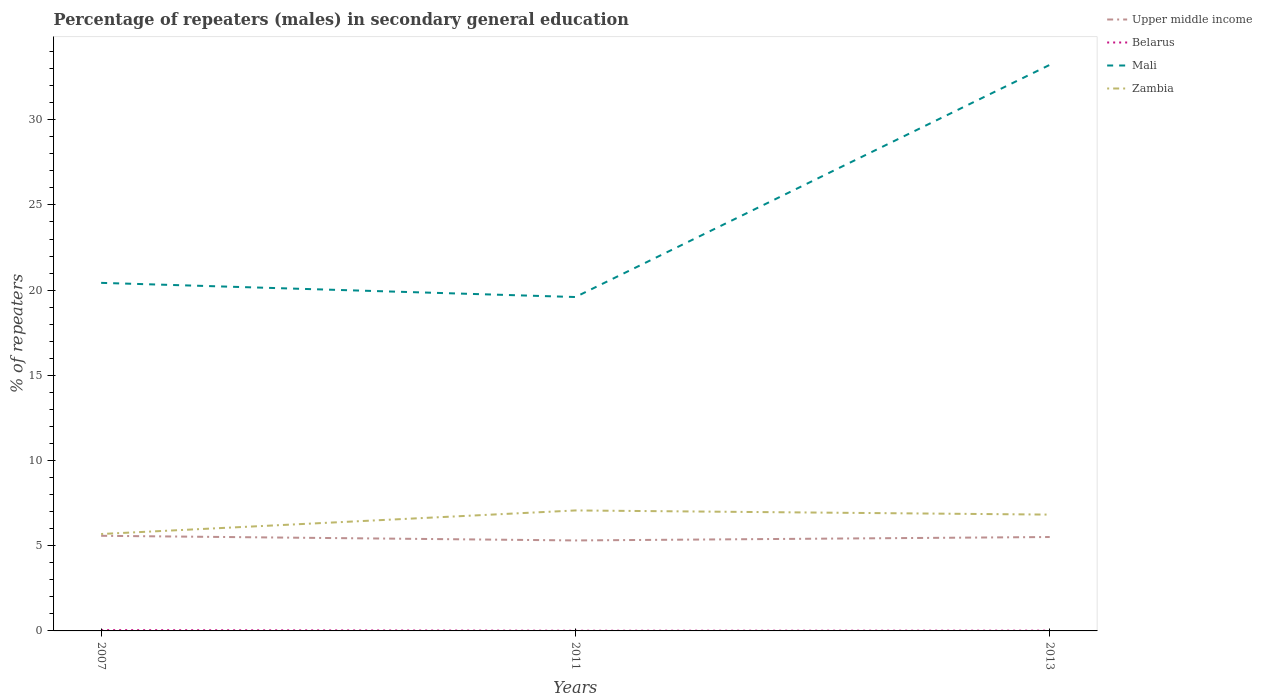How many different coloured lines are there?
Give a very brief answer. 4. Does the line corresponding to Belarus intersect with the line corresponding to Upper middle income?
Provide a short and direct response. No. Is the number of lines equal to the number of legend labels?
Offer a terse response. Yes. Across all years, what is the maximum percentage of male repeaters in Zambia?
Give a very brief answer. 5.69. In which year was the percentage of male repeaters in Upper middle income maximum?
Your answer should be compact. 2011. What is the total percentage of male repeaters in Upper middle income in the graph?
Offer a very short reply. 0.27. What is the difference between the highest and the second highest percentage of male repeaters in Mali?
Your answer should be compact. 13.63. What is the difference between the highest and the lowest percentage of male repeaters in Upper middle income?
Ensure brevity in your answer.  2. Is the percentage of male repeaters in Upper middle income strictly greater than the percentage of male repeaters in Zambia over the years?
Your response must be concise. Yes. What is the difference between two consecutive major ticks on the Y-axis?
Offer a terse response. 5. Does the graph contain grids?
Provide a short and direct response. No. What is the title of the graph?
Your answer should be compact. Percentage of repeaters (males) in secondary general education. What is the label or title of the X-axis?
Offer a very short reply. Years. What is the label or title of the Y-axis?
Your answer should be very brief. % of repeaters. What is the % of repeaters of Upper middle income in 2007?
Offer a very short reply. 5.58. What is the % of repeaters in Belarus in 2007?
Provide a short and direct response. 0.05. What is the % of repeaters in Mali in 2007?
Your answer should be very brief. 20.43. What is the % of repeaters of Zambia in 2007?
Your answer should be very brief. 5.69. What is the % of repeaters of Upper middle income in 2011?
Make the answer very short. 5.31. What is the % of repeaters of Belarus in 2011?
Ensure brevity in your answer.  0.01. What is the % of repeaters of Mali in 2011?
Give a very brief answer. 19.6. What is the % of repeaters of Zambia in 2011?
Make the answer very short. 7.07. What is the % of repeaters in Upper middle income in 2013?
Your answer should be very brief. 5.51. What is the % of repeaters in Belarus in 2013?
Your answer should be compact. 0.02. What is the % of repeaters in Mali in 2013?
Your answer should be compact. 33.22. What is the % of repeaters of Zambia in 2013?
Your response must be concise. 6.83. Across all years, what is the maximum % of repeaters of Upper middle income?
Your response must be concise. 5.58. Across all years, what is the maximum % of repeaters in Belarus?
Offer a very short reply. 0.05. Across all years, what is the maximum % of repeaters of Mali?
Keep it short and to the point. 33.22. Across all years, what is the maximum % of repeaters in Zambia?
Offer a terse response. 7.07. Across all years, what is the minimum % of repeaters in Upper middle income?
Your answer should be very brief. 5.31. Across all years, what is the minimum % of repeaters in Belarus?
Keep it short and to the point. 0.01. Across all years, what is the minimum % of repeaters in Mali?
Provide a short and direct response. 19.6. Across all years, what is the minimum % of repeaters in Zambia?
Provide a succinct answer. 5.69. What is the total % of repeaters in Upper middle income in the graph?
Give a very brief answer. 16.41. What is the total % of repeaters of Belarus in the graph?
Keep it short and to the point. 0.08. What is the total % of repeaters in Mali in the graph?
Keep it short and to the point. 73.25. What is the total % of repeaters in Zambia in the graph?
Ensure brevity in your answer.  19.59. What is the difference between the % of repeaters in Upper middle income in 2007 and that in 2011?
Give a very brief answer. 0.27. What is the difference between the % of repeaters in Belarus in 2007 and that in 2011?
Ensure brevity in your answer.  0.04. What is the difference between the % of repeaters in Mali in 2007 and that in 2011?
Offer a very short reply. 0.83. What is the difference between the % of repeaters in Zambia in 2007 and that in 2011?
Provide a short and direct response. -1.38. What is the difference between the % of repeaters in Upper middle income in 2007 and that in 2013?
Give a very brief answer. 0.07. What is the difference between the % of repeaters of Belarus in 2007 and that in 2013?
Provide a succinct answer. 0.03. What is the difference between the % of repeaters in Mali in 2007 and that in 2013?
Provide a short and direct response. -12.79. What is the difference between the % of repeaters in Zambia in 2007 and that in 2013?
Offer a very short reply. -1.14. What is the difference between the % of repeaters of Upper middle income in 2011 and that in 2013?
Offer a terse response. -0.2. What is the difference between the % of repeaters of Belarus in 2011 and that in 2013?
Your answer should be very brief. -0. What is the difference between the % of repeaters in Mali in 2011 and that in 2013?
Keep it short and to the point. -13.63. What is the difference between the % of repeaters of Zambia in 2011 and that in 2013?
Provide a short and direct response. 0.24. What is the difference between the % of repeaters in Upper middle income in 2007 and the % of repeaters in Belarus in 2011?
Provide a succinct answer. 5.57. What is the difference between the % of repeaters of Upper middle income in 2007 and the % of repeaters of Mali in 2011?
Ensure brevity in your answer.  -14.01. What is the difference between the % of repeaters of Upper middle income in 2007 and the % of repeaters of Zambia in 2011?
Offer a very short reply. -1.49. What is the difference between the % of repeaters in Belarus in 2007 and the % of repeaters in Mali in 2011?
Offer a terse response. -19.55. What is the difference between the % of repeaters in Belarus in 2007 and the % of repeaters in Zambia in 2011?
Your answer should be compact. -7.02. What is the difference between the % of repeaters of Mali in 2007 and the % of repeaters of Zambia in 2011?
Make the answer very short. 13.36. What is the difference between the % of repeaters of Upper middle income in 2007 and the % of repeaters of Belarus in 2013?
Offer a very short reply. 5.57. What is the difference between the % of repeaters in Upper middle income in 2007 and the % of repeaters in Mali in 2013?
Ensure brevity in your answer.  -27.64. What is the difference between the % of repeaters of Upper middle income in 2007 and the % of repeaters of Zambia in 2013?
Give a very brief answer. -1.24. What is the difference between the % of repeaters in Belarus in 2007 and the % of repeaters in Mali in 2013?
Ensure brevity in your answer.  -33.17. What is the difference between the % of repeaters of Belarus in 2007 and the % of repeaters of Zambia in 2013?
Give a very brief answer. -6.78. What is the difference between the % of repeaters in Mali in 2007 and the % of repeaters in Zambia in 2013?
Offer a terse response. 13.6. What is the difference between the % of repeaters of Upper middle income in 2011 and the % of repeaters of Belarus in 2013?
Offer a very short reply. 5.29. What is the difference between the % of repeaters of Upper middle income in 2011 and the % of repeaters of Mali in 2013?
Keep it short and to the point. -27.91. What is the difference between the % of repeaters of Upper middle income in 2011 and the % of repeaters of Zambia in 2013?
Keep it short and to the point. -1.52. What is the difference between the % of repeaters of Belarus in 2011 and the % of repeaters of Mali in 2013?
Keep it short and to the point. -33.21. What is the difference between the % of repeaters in Belarus in 2011 and the % of repeaters in Zambia in 2013?
Provide a short and direct response. -6.81. What is the difference between the % of repeaters of Mali in 2011 and the % of repeaters of Zambia in 2013?
Give a very brief answer. 12.77. What is the average % of repeaters in Upper middle income per year?
Your answer should be very brief. 5.47. What is the average % of repeaters of Belarus per year?
Your response must be concise. 0.03. What is the average % of repeaters in Mali per year?
Provide a short and direct response. 24.42. What is the average % of repeaters in Zambia per year?
Offer a very short reply. 6.53. In the year 2007, what is the difference between the % of repeaters in Upper middle income and % of repeaters in Belarus?
Your answer should be very brief. 5.53. In the year 2007, what is the difference between the % of repeaters of Upper middle income and % of repeaters of Mali?
Your response must be concise. -14.84. In the year 2007, what is the difference between the % of repeaters in Upper middle income and % of repeaters in Zambia?
Provide a short and direct response. -0.11. In the year 2007, what is the difference between the % of repeaters in Belarus and % of repeaters in Mali?
Offer a very short reply. -20.38. In the year 2007, what is the difference between the % of repeaters in Belarus and % of repeaters in Zambia?
Ensure brevity in your answer.  -5.64. In the year 2007, what is the difference between the % of repeaters in Mali and % of repeaters in Zambia?
Keep it short and to the point. 14.74. In the year 2011, what is the difference between the % of repeaters in Upper middle income and % of repeaters in Belarus?
Your answer should be very brief. 5.3. In the year 2011, what is the difference between the % of repeaters of Upper middle income and % of repeaters of Mali?
Keep it short and to the point. -14.29. In the year 2011, what is the difference between the % of repeaters of Upper middle income and % of repeaters of Zambia?
Keep it short and to the point. -1.76. In the year 2011, what is the difference between the % of repeaters in Belarus and % of repeaters in Mali?
Your answer should be compact. -19.58. In the year 2011, what is the difference between the % of repeaters in Belarus and % of repeaters in Zambia?
Offer a terse response. -7.06. In the year 2011, what is the difference between the % of repeaters of Mali and % of repeaters of Zambia?
Your response must be concise. 12.53. In the year 2013, what is the difference between the % of repeaters of Upper middle income and % of repeaters of Belarus?
Ensure brevity in your answer.  5.5. In the year 2013, what is the difference between the % of repeaters in Upper middle income and % of repeaters in Mali?
Your response must be concise. -27.71. In the year 2013, what is the difference between the % of repeaters of Upper middle income and % of repeaters of Zambia?
Provide a succinct answer. -1.31. In the year 2013, what is the difference between the % of repeaters in Belarus and % of repeaters in Mali?
Keep it short and to the point. -33.21. In the year 2013, what is the difference between the % of repeaters of Belarus and % of repeaters of Zambia?
Your answer should be very brief. -6.81. In the year 2013, what is the difference between the % of repeaters in Mali and % of repeaters in Zambia?
Your answer should be compact. 26.4. What is the ratio of the % of repeaters in Upper middle income in 2007 to that in 2011?
Your response must be concise. 1.05. What is the ratio of the % of repeaters in Belarus in 2007 to that in 2011?
Give a very brief answer. 4.14. What is the ratio of the % of repeaters in Mali in 2007 to that in 2011?
Make the answer very short. 1.04. What is the ratio of the % of repeaters in Zambia in 2007 to that in 2011?
Make the answer very short. 0.8. What is the ratio of the % of repeaters of Upper middle income in 2007 to that in 2013?
Offer a very short reply. 1.01. What is the ratio of the % of repeaters in Belarus in 2007 to that in 2013?
Make the answer very short. 2.98. What is the ratio of the % of repeaters of Mali in 2007 to that in 2013?
Provide a succinct answer. 0.61. What is the ratio of the % of repeaters of Zambia in 2007 to that in 2013?
Your answer should be very brief. 0.83. What is the ratio of the % of repeaters in Upper middle income in 2011 to that in 2013?
Your answer should be compact. 0.96. What is the ratio of the % of repeaters in Belarus in 2011 to that in 2013?
Your answer should be compact. 0.72. What is the ratio of the % of repeaters of Mali in 2011 to that in 2013?
Offer a very short reply. 0.59. What is the ratio of the % of repeaters of Zambia in 2011 to that in 2013?
Offer a terse response. 1.04. What is the difference between the highest and the second highest % of repeaters in Upper middle income?
Provide a succinct answer. 0.07. What is the difference between the highest and the second highest % of repeaters in Belarus?
Make the answer very short. 0.03. What is the difference between the highest and the second highest % of repeaters of Mali?
Offer a very short reply. 12.79. What is the difference between the highest and the second highest % of repeaters in Zambia?
Offer a very short reply. 0.24. What is the difference between the highest and the lowest % of repeaters in Upper middle income?
Your answer should be very brief. 0.27. What is the difference between the highest and the lowest % of repeaters in Belarus?
Your response must be concise. 0.04. What is the difference between the highest and the lowest % of repeaters of Mali?
Your response must be concise. 13.63. What is the difference between the highest and the lowest % of repeaters of Zambia?
Keep it short and to the point. 1.38. 